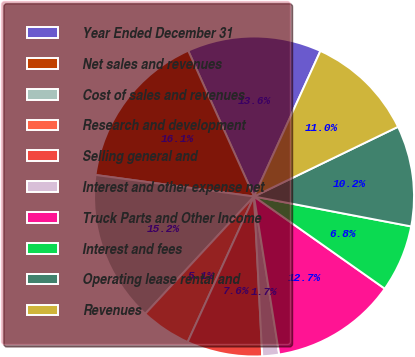<chart> <loc_0><loc_0><loc_500><loc_500><pie_chart><fcel>Year Ended December 31<fcel>Net sales and revenues<fcel>Cost of sales and revenues<fcel>Research and development<fcel>Selling general and<fcel>Interest and other expense net<fcel>Truck Parts and Other Income<fcel>Interest and fees<fcel>Operating lease rental and<fcel>Revenues<nl><fcel>13.56%<fcel>16.1%<fcel>15.25%<fcel>5.09%<fcel>7.63%<fcel>1.7%<fcel>12.71%<fcel>6.78%<fcel>10.17%<fcel>11.02%<nl></chart> 